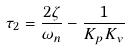Convert formula to latex. <formula><loc_0><loc_0><loc_500><loc_500>\tau _ { 2 } = \frac { 2 \zeta } { \omega _ { n } } - \frac { 1 } { K _ { p } K _ { v } }</formula> 